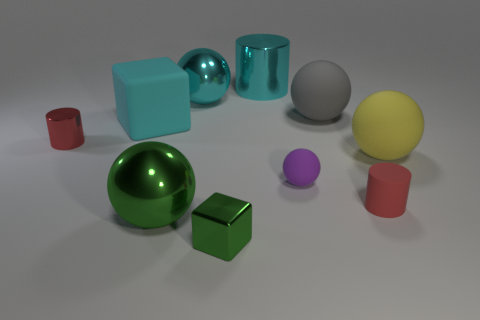Subtract all cyan metallic cylinders. How many cylinders are left? 2 Subtract all cyan cubes. How many cubes are left? 1 Subtract all green spheres. How many red cylinders are left? 2 Subtract all big brown cylinders. Subtract all tiny red cylinders. How many objects are left? 8 Add 5 blocks. How many blocks are left? 7 Add 2 large shiny cylinders. How many large shiny cylinders exist? 3 Subtract 0 red spheres. How many objects are left? 10 Subtract all cylinders. How many objects are left? 7 Subtract 2 cubes. How many cubes are left? 0 Subtract all green cubes. Subtract all brown cylinders. How many cubes are left? 1 